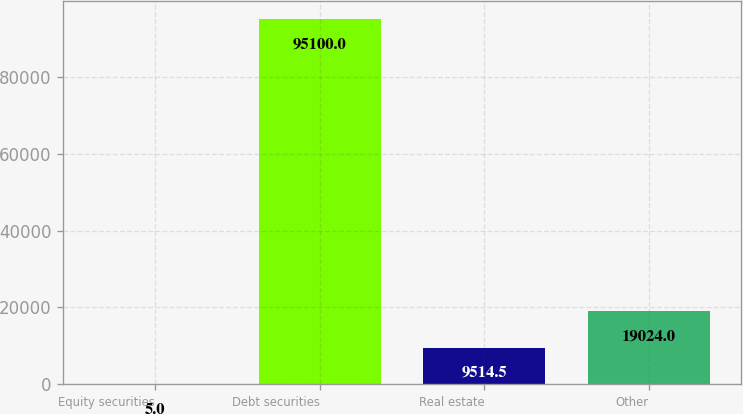<chart> <loc_0><loc_0><loc_500><loc_500><bar_chart><fcel>Equity securities<fcel>Debt securities<fcel>Real estate<fcel>Other<nl><fcel>5<fcel>95100<fcel>9514.5<fcel>19024<nl></chart> 